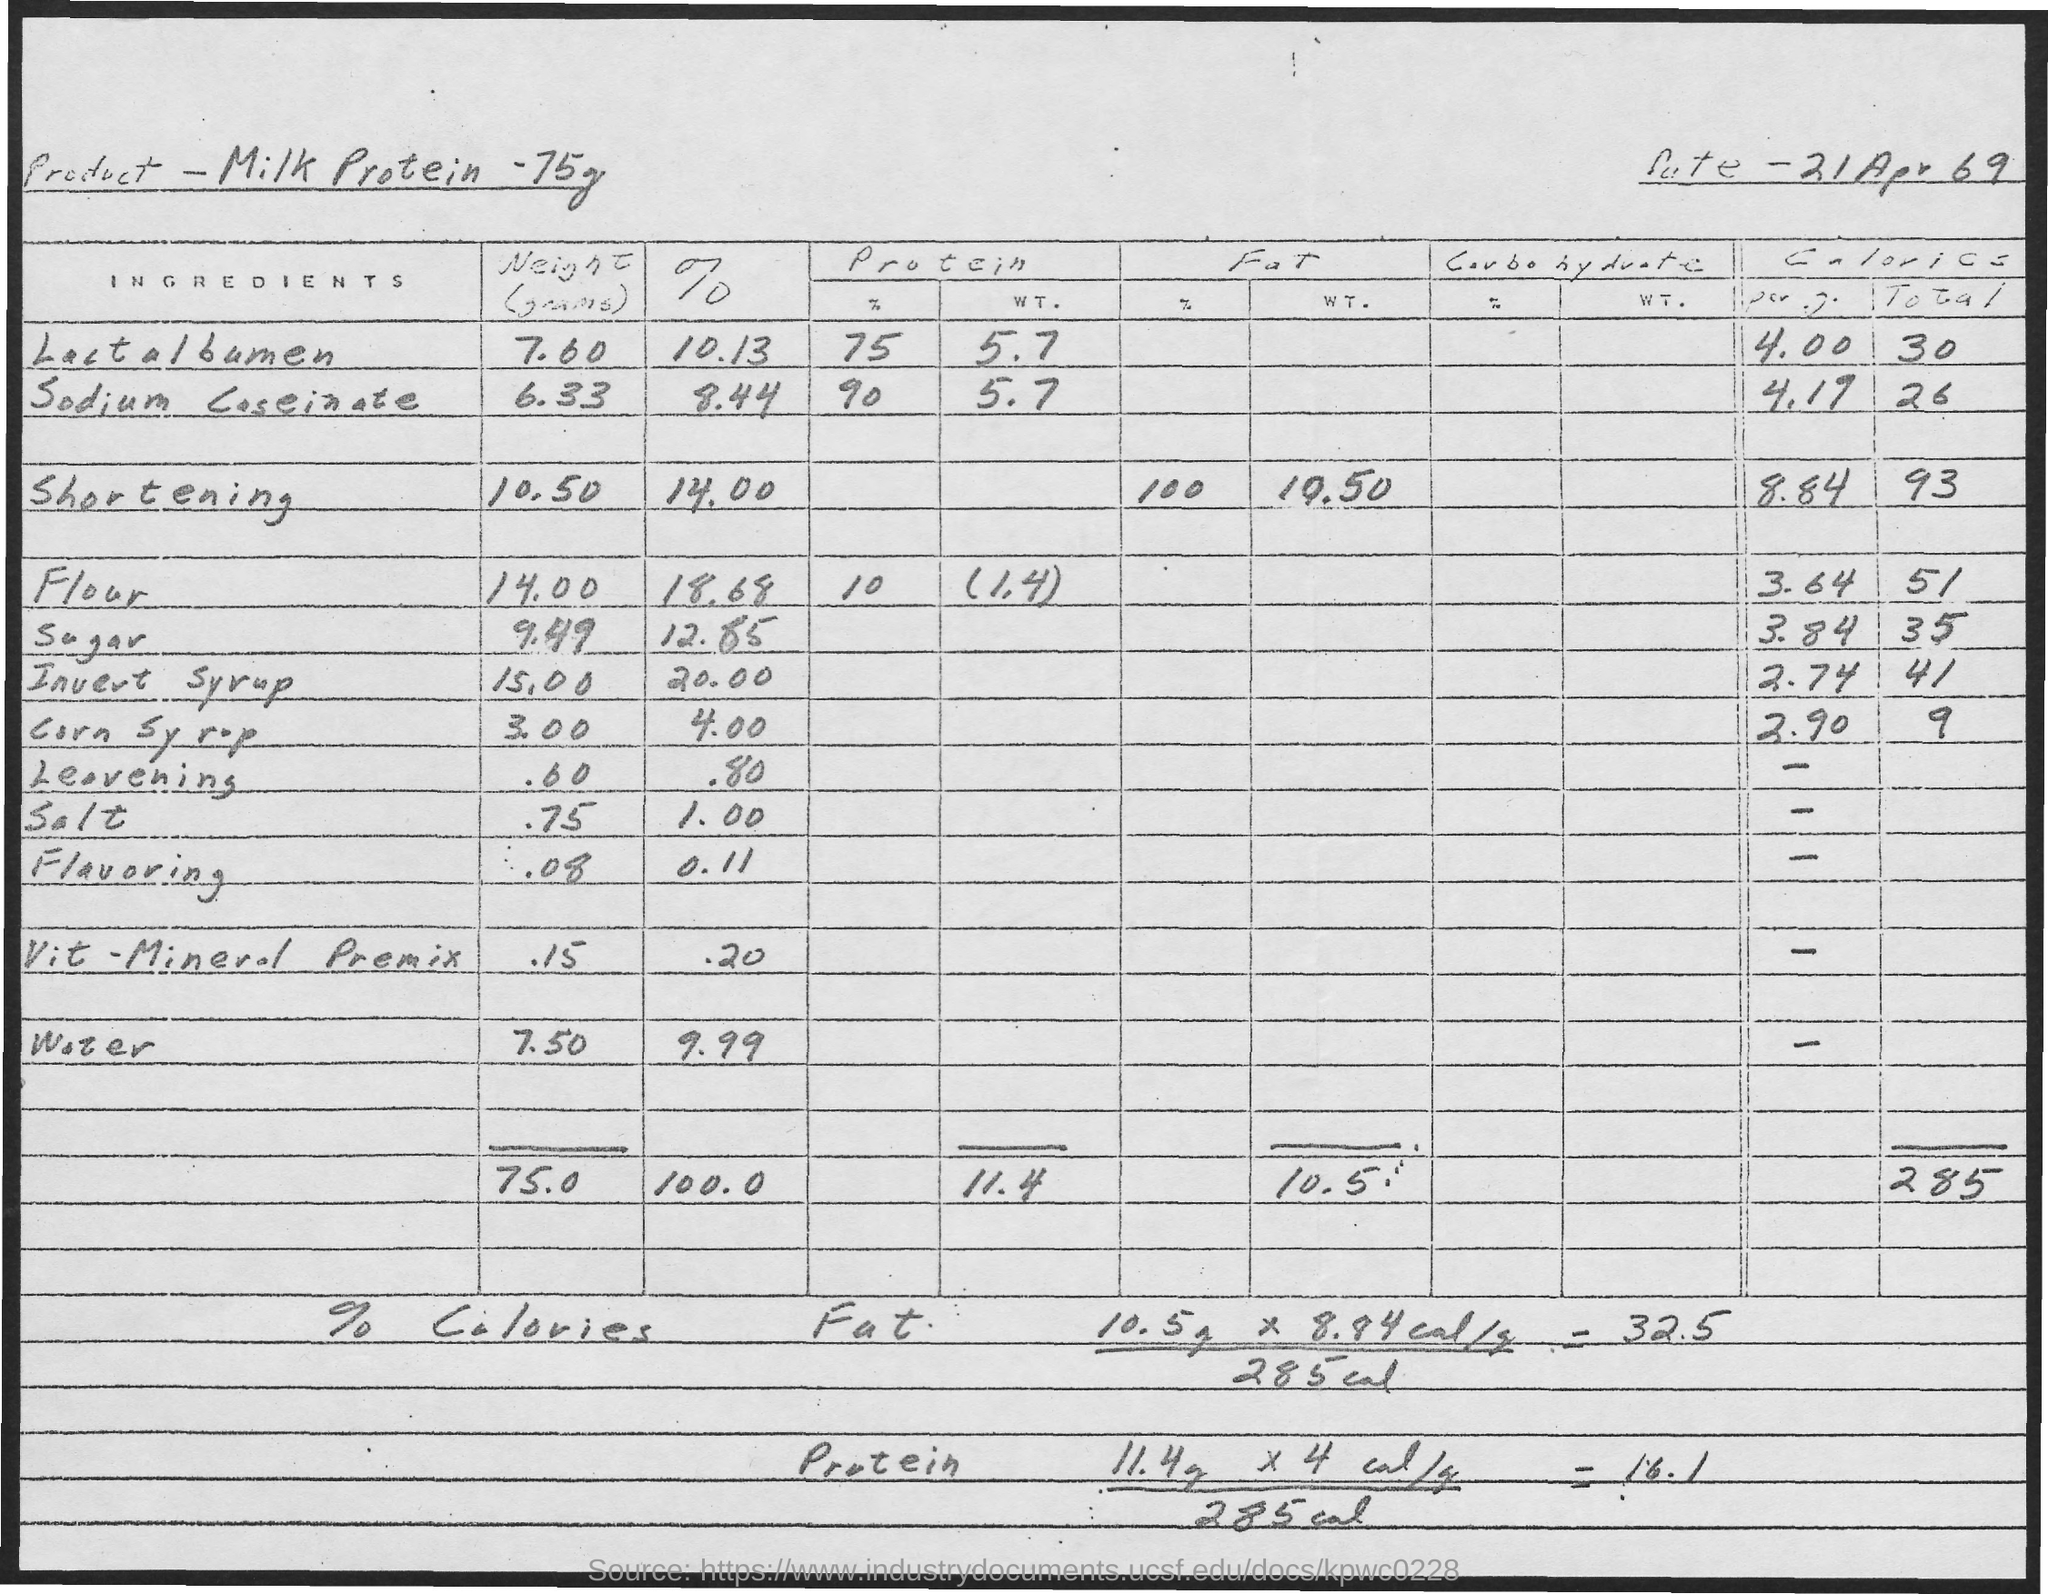What is the Date?
Provide a short and direct response. 21 Apr 69. What is the weight of Lactalbumin in Milk protein - 75g?
Keep it short and to the point. 7.60. What is the weight of shortening in Milk protein - 75g?
Provide a short and direct response. 10.50. What is the % of Lactalbumin in Milk protein - 75g?
Your response must be concise. 10.13. What is the % of shortening in Milk protein - 75g?
Your answer should be compact. 14.00. What is the weight of flour in Milk protein - 75g?
Provide a short and direct response. 14.00. What is the weight of sugar in Milk protein - 75g?
Provide a succinct answer. 9.49. What is the % of flour in Milk protein - 75g?
Offer a very short reply. 18.68. What is the % of sugar in Milk protein - 75g?
Offer a terse response. 12.85. What is the weight of water in Milk protein - 75g?
Your answer should be very brief. 7.50. 